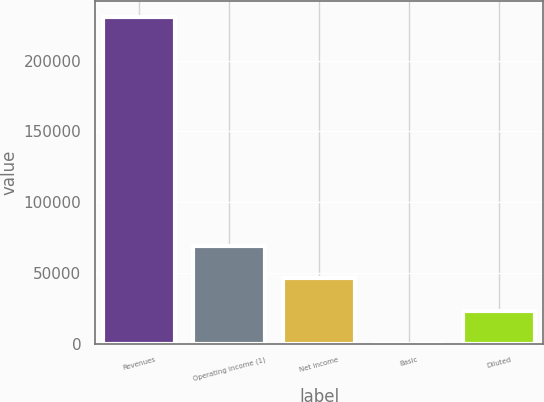Convert chart to OTSL. <chart><loc_0><loc_0><loc_500><loc_500><bar_chart><fcel>Revenues<fcel>Operating income (1)<fcel>Net income<fcel>Basic<fcel>Diluted<nl><fcel>230929<fcel>69278.7<fcel>46185.8<fcel>0.07<fcel>23093<nl></chart> 